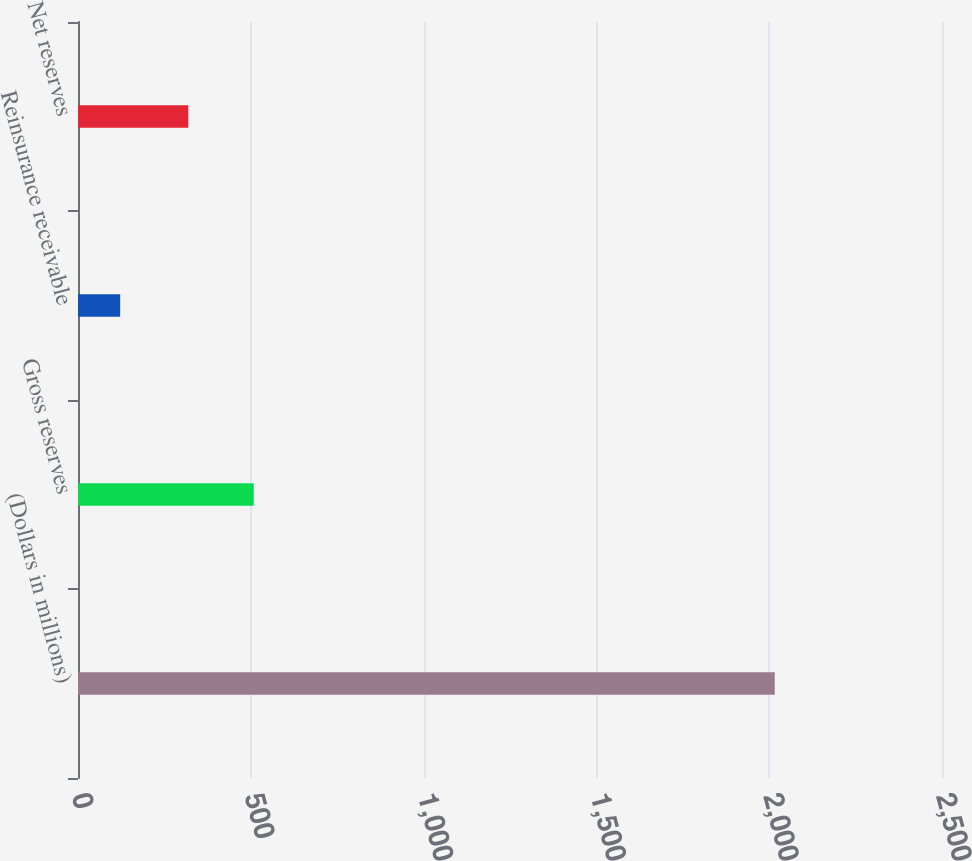<chart> <loc_0><loc_0><loc_500><loc_500><bar_chart><fcel>(Dollars in millions)<fcel>Gross reserves<fcel>Reinsurance receivable<fcel>Net reserves<nl><fcel>2016<fcel>508.5<fcel>122<fcel>319.1<nl></chart> 